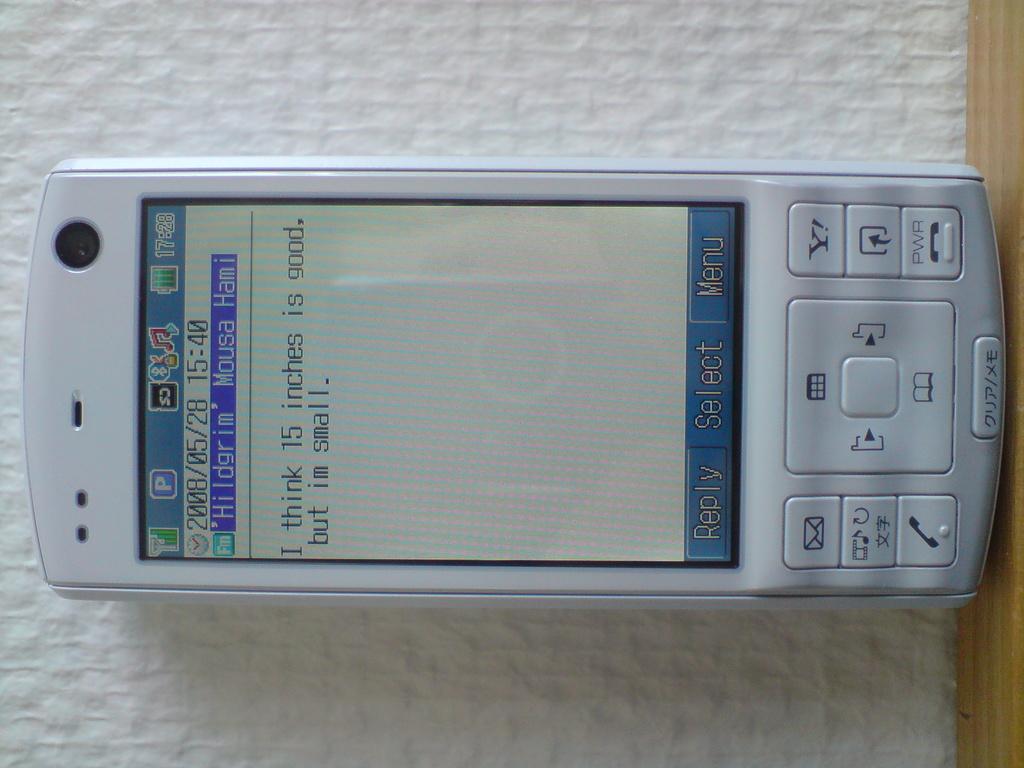In what year was this text written?
Your answer should be very brief. 2008. What is one of the options at the bottom of the phone?
Offer a very short reply. Reply. 